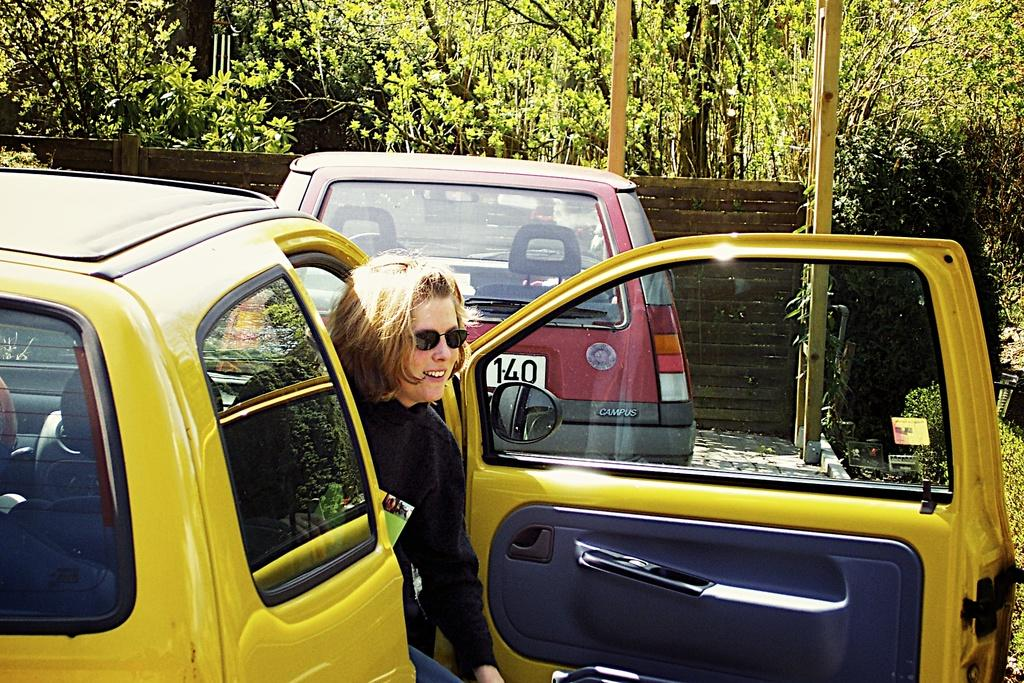Provide a one-sentence caption for the provided image. a lady in a yellow car behind a car that has 140 on it. 